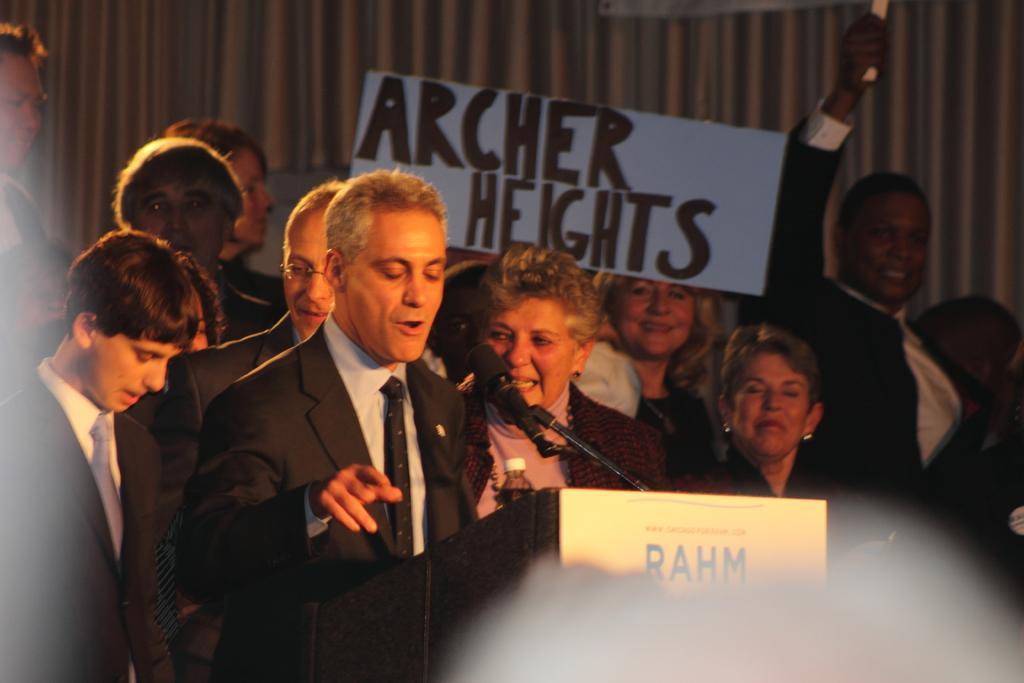How would you summarize this image in a sentence or two? In the image there is a man in black suit talking on mic, in the background there are many people standing, in the middle there is a banner on the wall. 